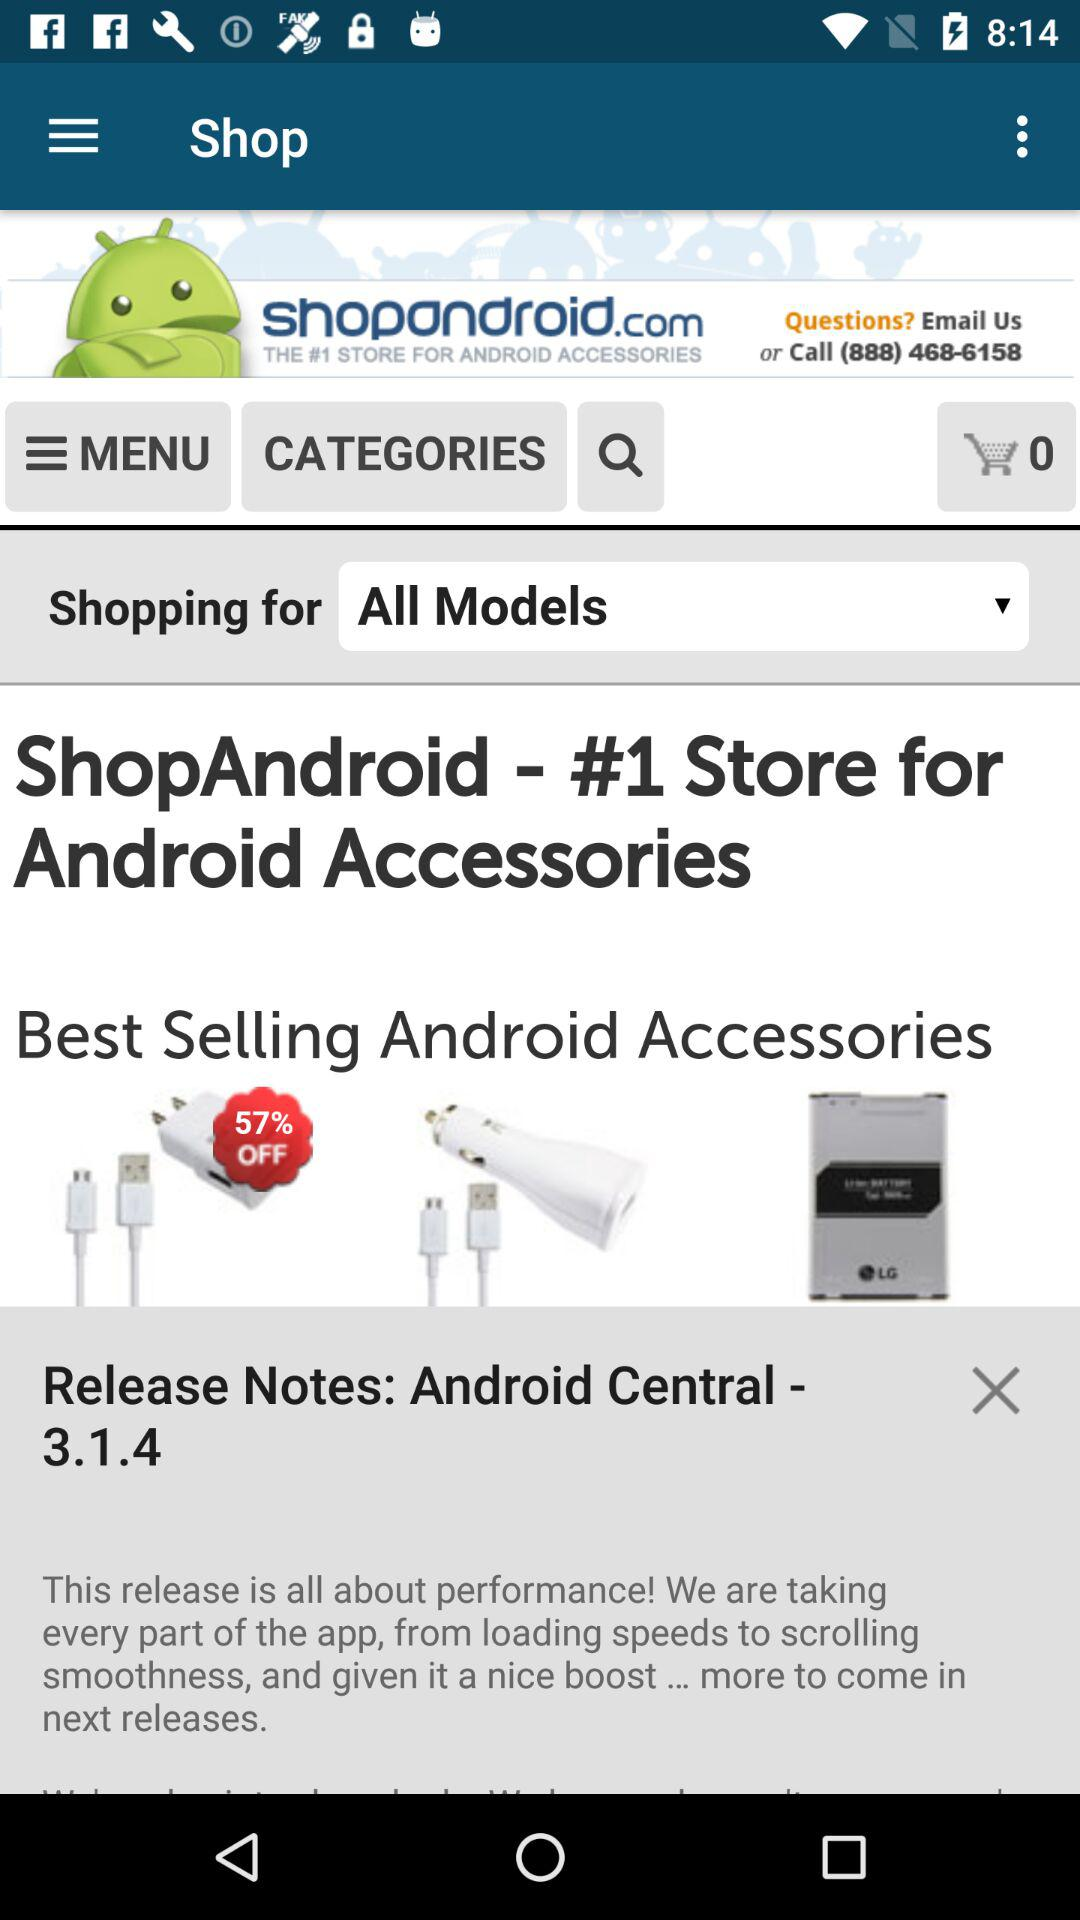How many items are in the cart? There are 0 items in the cart. 